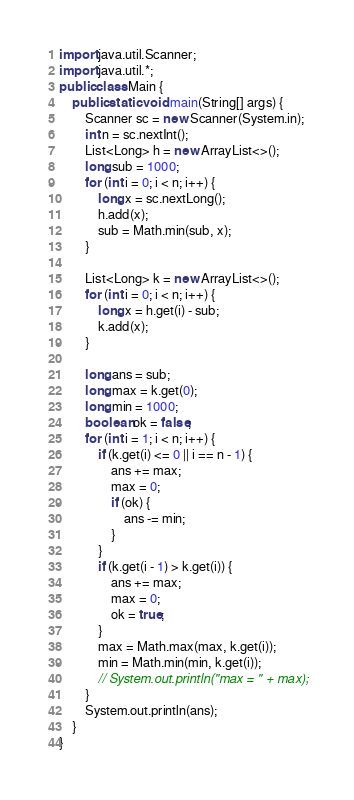Convert code to text. <code><loc_0><loc_0><loc_500><loc_500><_Java_>import java.util.Scanner;
import java.util.*;
public class Main {
    public static void main(String[] args) {
        Scanner sc = new Scanner(System.in);
        int n = sc.nextInt();
        List<Long> h = new ArrayList<>();
        long sub = 1000;
        for (int i = 0; i < n; i++) {
            long x = sc.nextLong();
            h.add(x);
            sub = Math.min(sub, x);
        }

        List<Long> k = new ArrayList<>();
        for (int i = 0; i < n; i++) {
            long x = h.get(i) - sub;
            k.add(x);
        }

        long ans = sub;
        long max = k.get(0);
        long min = 1000;
        boolean ok = false;
        for (int i = 1; i < n; i++) {
            if (k.get(i) <= 0 || i == n - 1) {
                ans += max;
                max = 0;
                if (ok) {
                    ans -= min;
                }
            }
            if (k.get(i - 1) > k.get(i)) {
                ans += max;
                max = 0;
                ok = true;
            }
            max = Math.max(max, k.get(i));
            min = Math.min(min, k.get(i));
            // System.out.println("max = " + max);
        }
        System.out.println(ans);
    }
}
</code> 